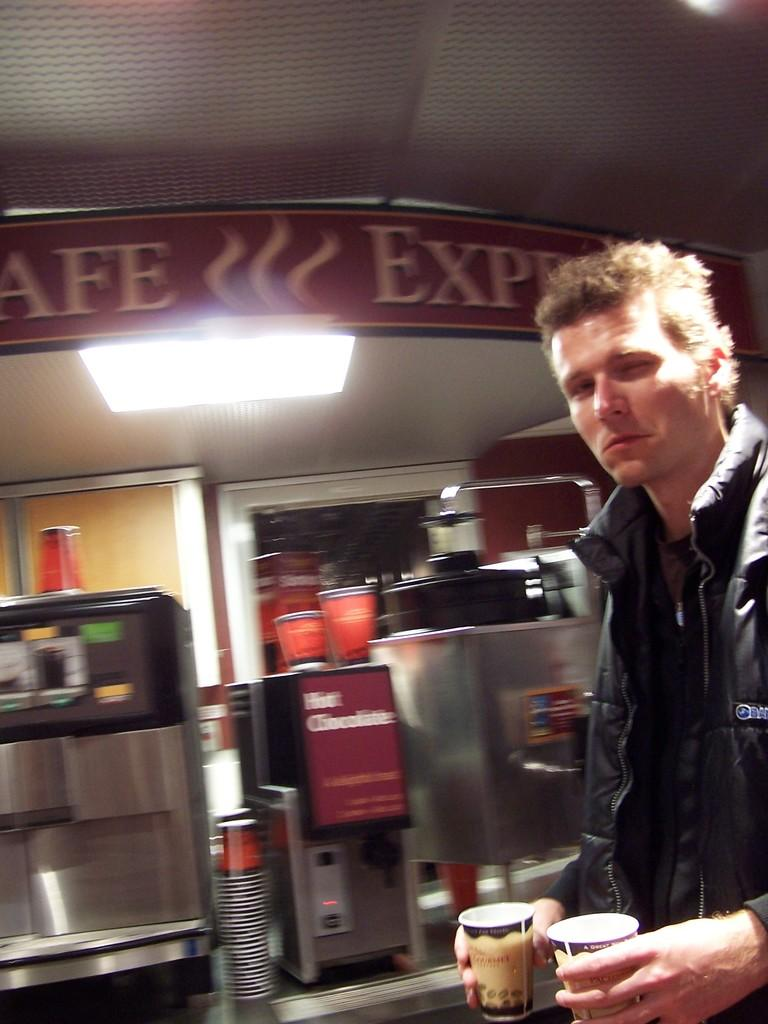<image>
Render a clear and concise summary of the photo. A man holding two cups of coffee and an sign over his head that says Cafe Express 